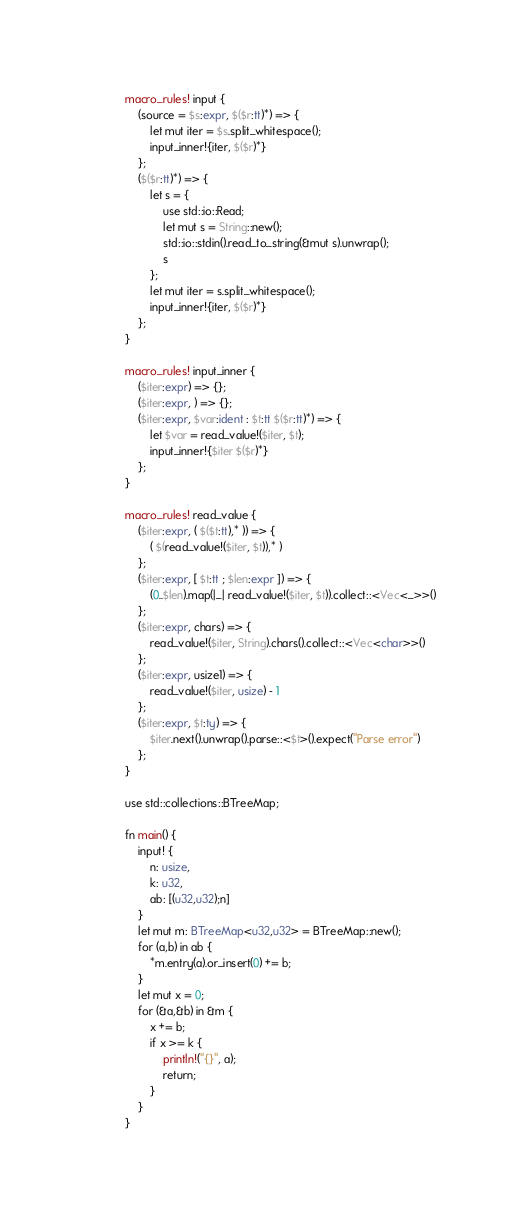Convert code to text. <code><loc_0><loc_0><loc_500><loc_500><_Rust_>macro_rules! input {
    (source = $s:expr, $($r:tt)*) => {
        let mut iter = $s.split_whitespace();
        input_inner!{iter, $($r)*}
    };
    ($($r:tt)*) => {
        let s = {
            use std::io::Read;
            let mut s = String::new();
            std::io::stdin().read_to_string(&mut s).unwrap();
            s
        };
        let mut iter = s.split_whitespace();
        input_inner!{iter, $($r)*}
    };
}

macro_rules! input_inner {
    ($iter:expr) => {};
    ($iter:expr, ) => {};
    ($iter:expr, $var:ident : $t:tt $($r:tt)*) => {
        let $var = read_value!($iter, $t);
        input_inner!{$iter $($r)*}
    };
}

macro_rules! read_value {
    ($iter:expr, ( $($t:tt),* )) => {
        ( $(read_value!($iter, $t)),* )
    };
    ($iter:expr, [ $t:tt ; $len:expr ]) => {
        (0..$len).map(|_| read_value!($iter, $t)).collect::<Vec<_>>()
    };
    ($iter:expr, chars) => {
        read_value!($iter, String).chars().collect::<Vec<char>>()
    };
    ($iter:expr, usize1) => {
        read_value!($iter, usize) - 1
    };
    ($iter:expr, $t:ty) => {
        $iter.next().unwrap().parse::<$t>().expect("Parse error")
    };
}

use std::collections::BTreeMap;

fn main() {
    input! {
        n: usize,
        k: u32,
        ab: [(u32,u32);n]
    }
    let mut m: BTreeMap<u32,u32> = BTreeMap::new();
    for (a,b) in ab {
        *m.entry(a).or_insert(0) += b;
    }
    let mut x = 0;
    for (&a,&b) in &m {
        x += b;
        if x >= k {
            println!("{}", a);
            return;
        }
    }
}
</code> 